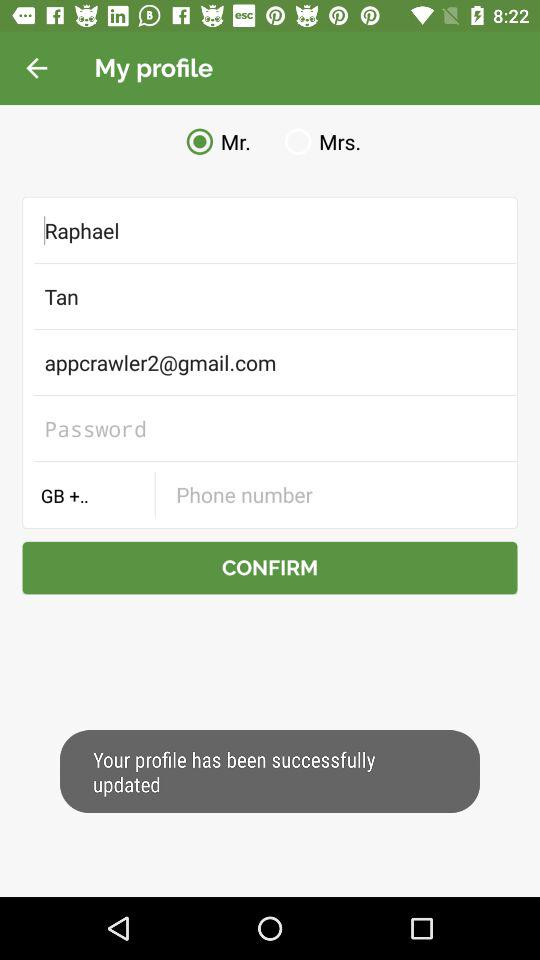What is the selected title to use before the name? The selected title is "Mr.". 